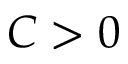Convert formula to latex. <formula><loc_0><loc_0><loc_500><loc_500>C > 0</formula> 